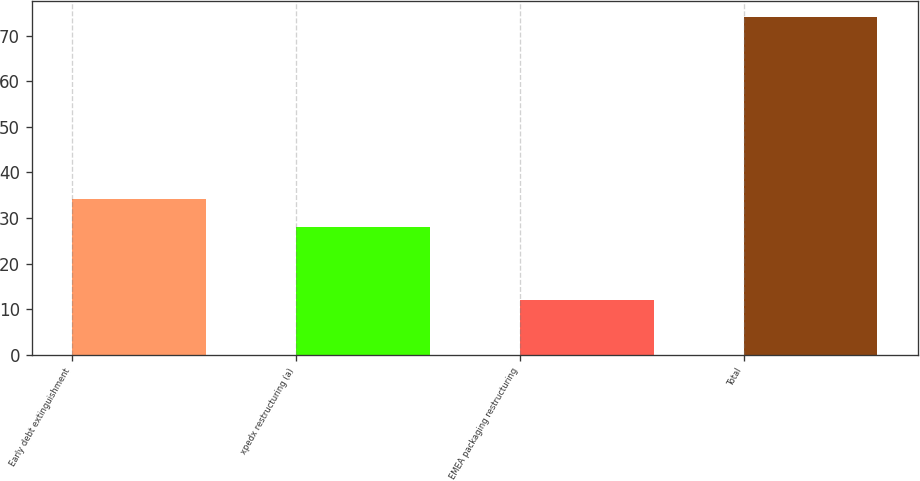Convert chart. <chart><loc_0><loc_0><loc_500><loc_500><bar_chart><fcel>Early debt extinguishment<fcel>xpedx restructuring (a)<fcel>EMEA packaging restructuring<fcel>Total<nl><fcel>34.2<fcel>28<fcel>12<fcel>74<nl></chart> 